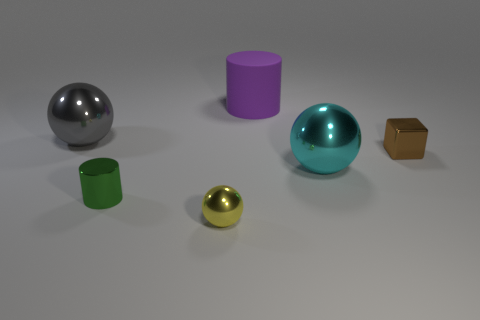Add 1 big blue rubber cubes. How many objects exist? 7 Subtract all cubes. How many objects are left? 5 Add 1 brown metal cubes. How many brown metal cubes are left? 2 Add 5 tiny brown cubes. How many tiny brown cubes exist? 6 Subtract 0 red blocks. How many objects are left? 6 Subtract all brown cubes. Subtract all blue metallic balls. How many objects are left? 5 